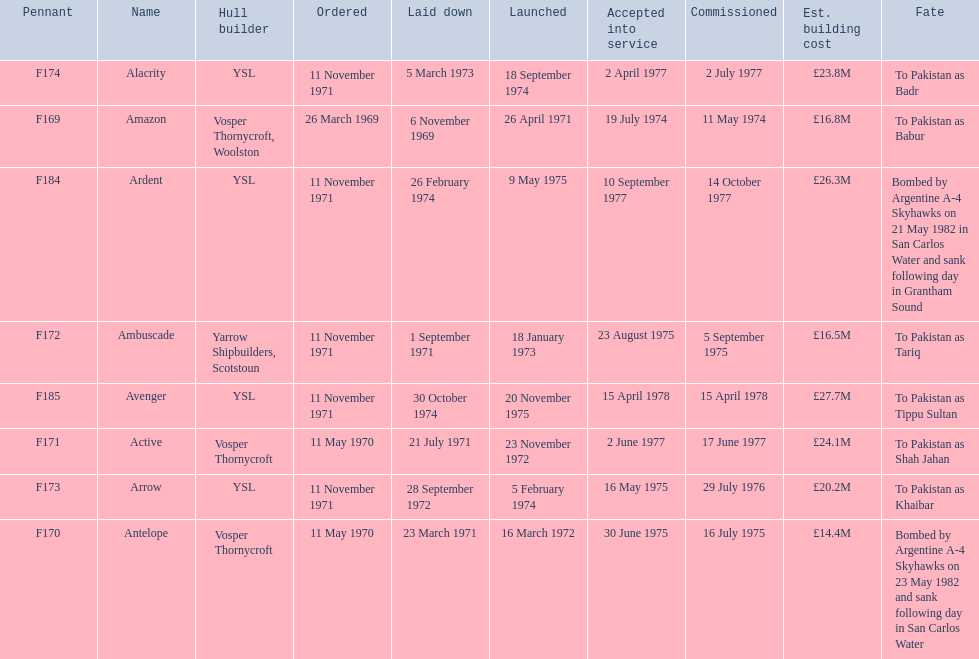What is the next pennant after f172? F173. 